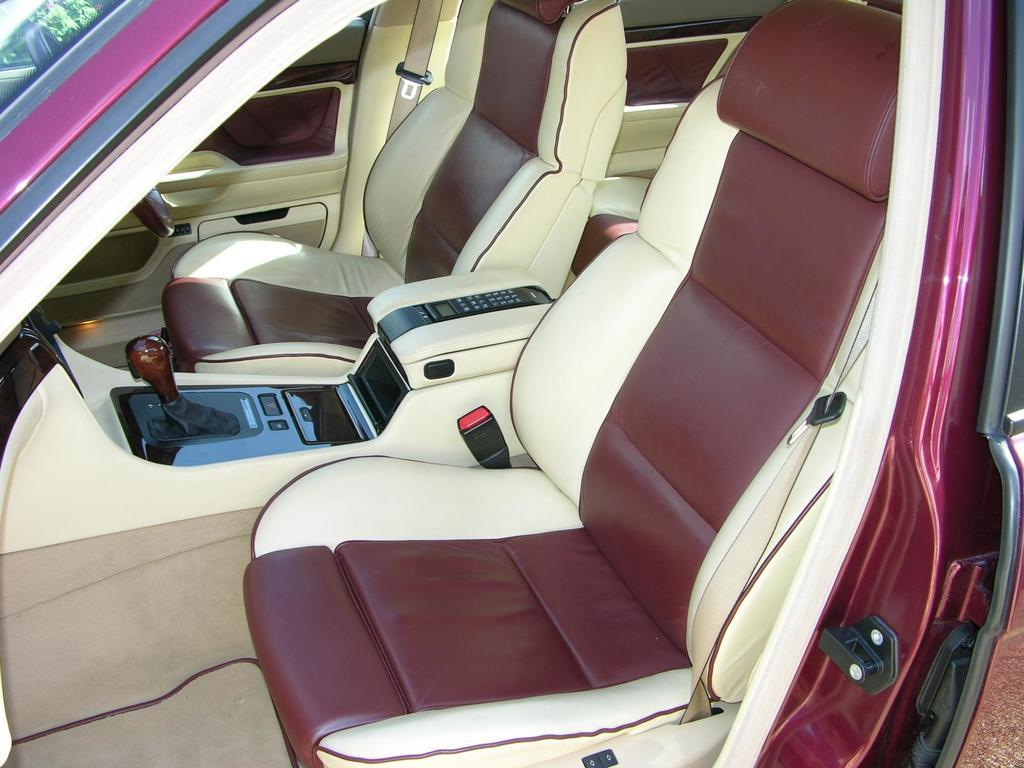What type of environment is depicted in the image? The image shows an inner view of a car. What can be found inside the car? There are seats and a gear in the car. How does the driver control the car's direction? The car has a steering wheel for controlling its direction. Can you tell me how many beggars are visible in the image? There are no beggars present in the image; it shows the interior of a car. What verse is being recited by the driver in the image? There is no indication of any recitation or verse in the image; it simply shows the car's interior. 